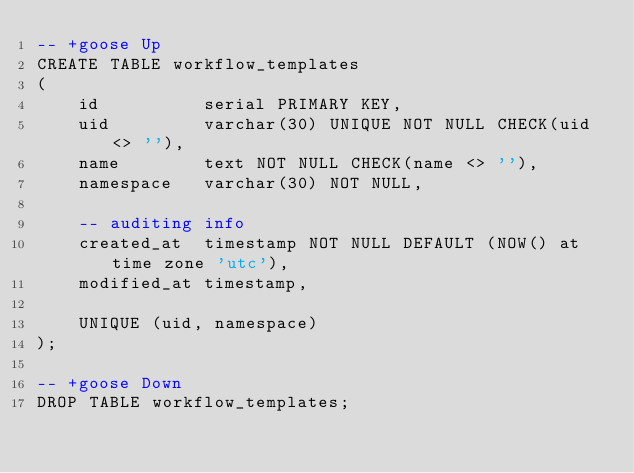Convert code to text. <code><loc_0><loc_0><loc_500><loc_500><_SQL_>-- +goose Up
CREATE TABLE workflow_templates
(
    id          serial PRIMARY KEY,
    uid         varchar(30) UNIQUE NOT NULL CHECK(uid <> ''),
    name        text NOT NULL CHECK(name <> ''),
    namespace   varchar(30) NOT NULL,

    -- auditing info
    created_at  timestamp NOT NULL DEFAULT (NOW() at time zone 'utc'),
    modified_at timestamp,

    UNIQUE (uid, namespace)
);

-- +goose Down
DROP TABLE workflow_templates;</code> 